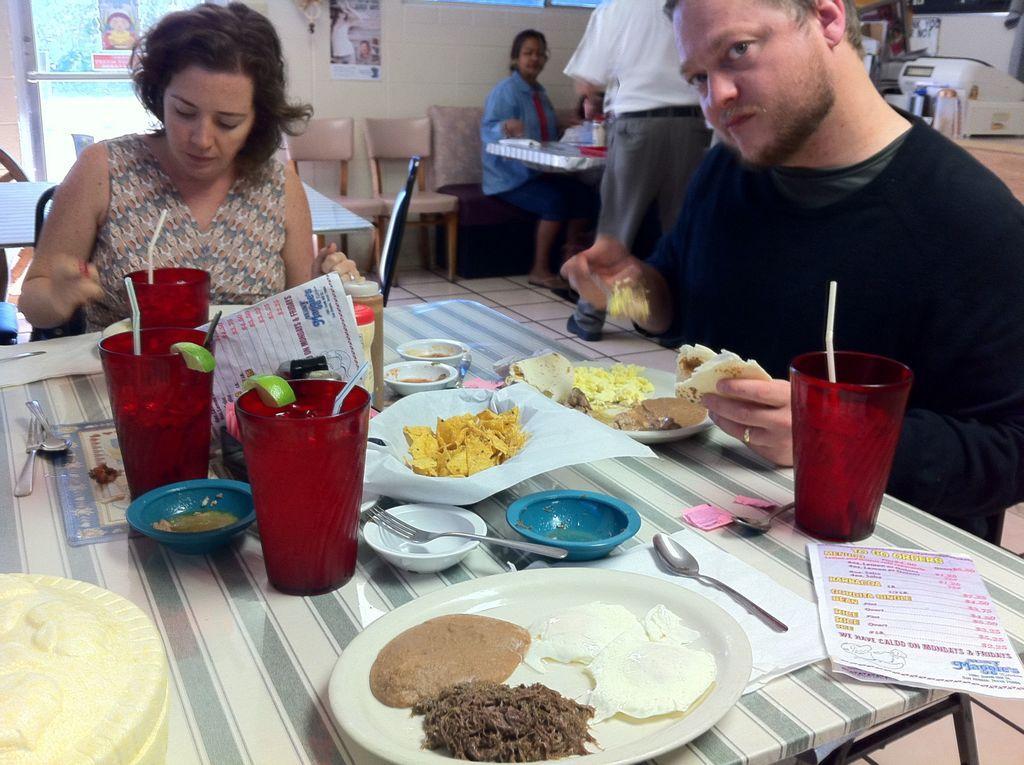Describe this image in one or two sentences. In this picture we can see inside view of the restaurant in which one man wearing black t- shirt is eating and seeing towards the camera, Beside we can see the a woman wearing colorful dress and watching in the plate, On the table we can see many dishes of food like bread chicken , chips glass. Behind we can see some poster on the wall. 